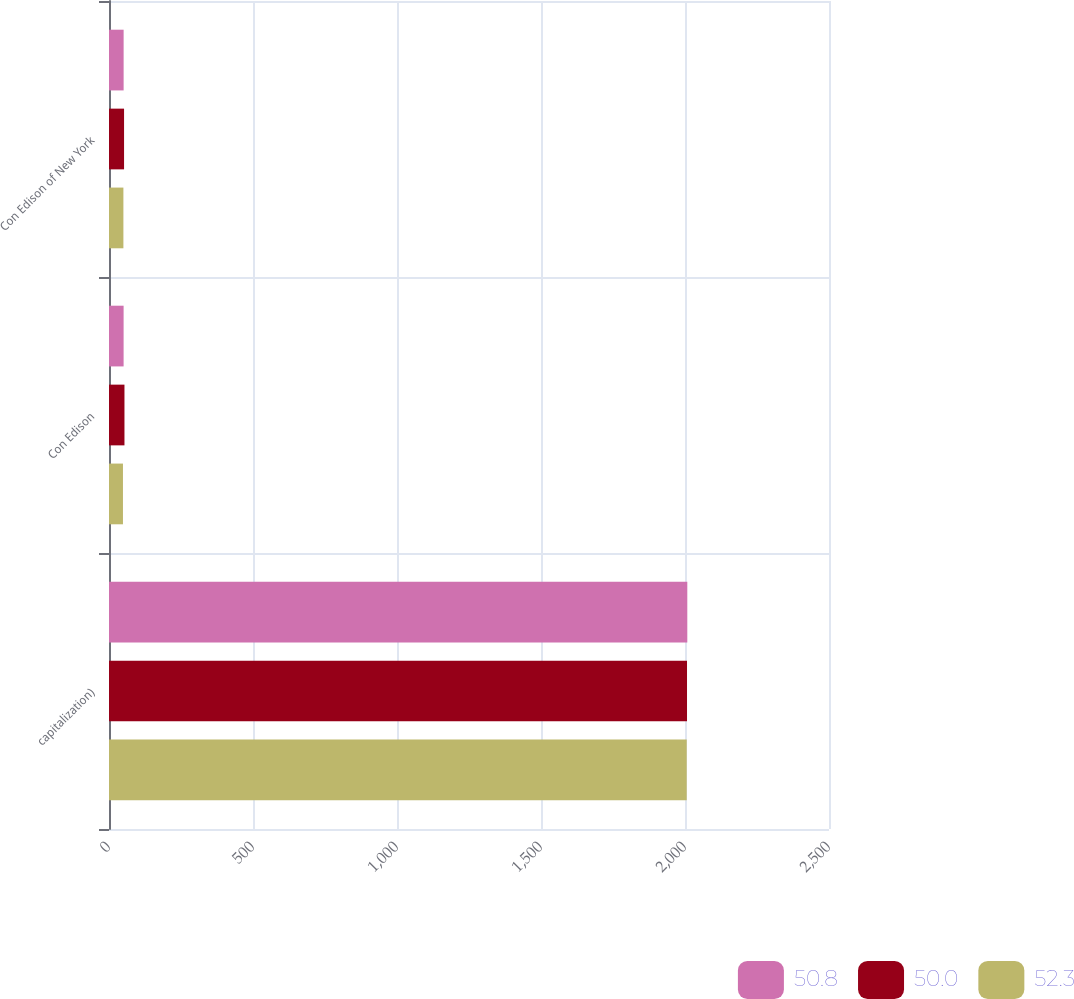Convert chart to OTSL. <chart><loc_0><loc_0><loc_500><loc_500><stacked_bar_chart><ecel><fcel>capitalization)<fcel>Con Edison<fcel>Con Edison of New York<nl><fcel>50.8<fcel>2008<fcel>50.7<fcel>50.8<nl><fcel>50<fcel>2007<fcel>53.7<fcel>52.3<nl><fcel>52.3<fcel>2006<fcel>48.5<fcel>50<nl></chart> 